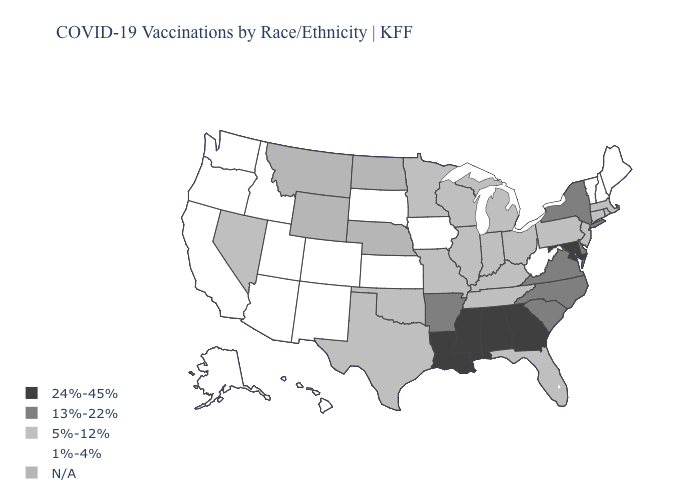What is the value of Washington?
Answer briefly. 1%-4%. What is the lowest value in the USA?
Be succinct. 1%-4%. What is the highest value in the USA?
Be succinct. 24%-45%. Does Hawaii have the lowest value in the USA?
Be succinct. Yes. Does Louisiana have the highest value in the USA?
Answer briefly. Yes. Does Illinois have the highest value in the USA?
Short answer required. No. What is the value of Iowa?
Answer briefly. 1%-4%. What is the value of Louisiana?
Answer briefly. 24%-45%. Among the states that border Alabama , which have the highest value?
Quick response, please. Georgia, Mississippi. Among the states that border Kentucky , which have the lowest value?
Quick response, please. West Virginia. What is the value of Vermont?
Quick response, please. 1%-4%. What is the value of Missouri?
Answer briefly. 5%-12%. Does Florida have the lowest value in the South?
Short answer required. No. Does the first symbol in the legend represent the smallest category?
Quick response, please. No. 